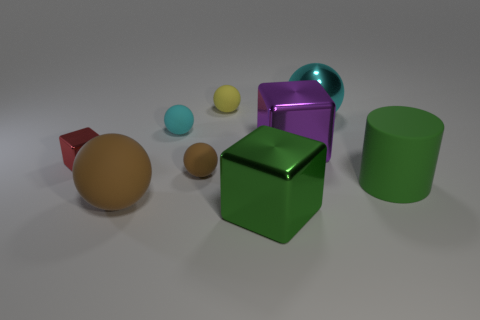Is there any object that stands out because of its size? Yes, the large purple hexahedron stands out because of its size in comparison to the other objects. 